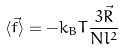<formula> <loc_0><loc_0><loc_500><loc_500>\langle \vec { f } \rangle = - k _ { B } T \frac { 3 \vec { R } } { N l ^ { 2 } }</formula> 